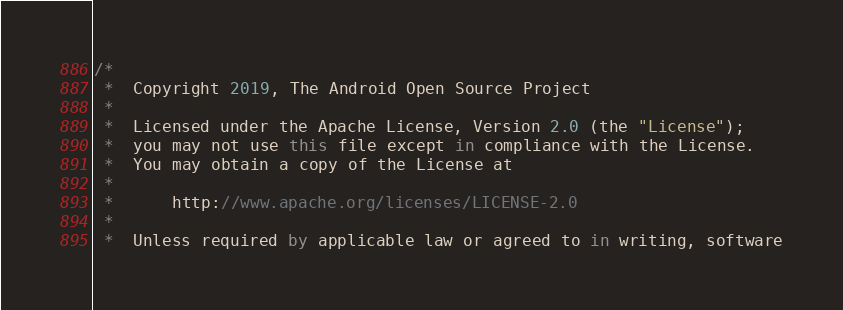<code> <loc_0><loc_0><loc_500><loc_500><_Kotlin_>/*
 *  Copyright 2019, The Android Open Source Project
 *
 *  Licensed under the Apache License, Version 2.0 (the "License");
 *  you may not use this file except in compliance with the License.
 *  You may obtain a copy of the License at
 *
 *      http://www.apache.org/licenses/LICENSE-2.0
 *
 *  Unless required by applicable law or agreed to in writing, software</code> 